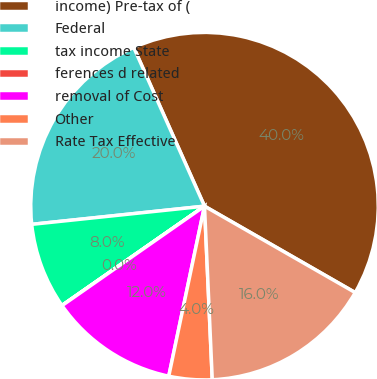Convert chart to OTSL. <chart><loc_0><loc_0><loc_500><loc_500><pie_chart><fcel>income) Pre-tax of (<fcel>Federal<fcel>tax income State<fcel>ferences d related<fcel>removal of Cost<fcel>Other<fcel>Rate Tax Effective<nl><fcel>39.96%<fcel>19.99%<fcel>8.01%<fcel>0.02%<fcel>12.0%<fcel>4.01%<fcel>16.0%<nl></chart> 